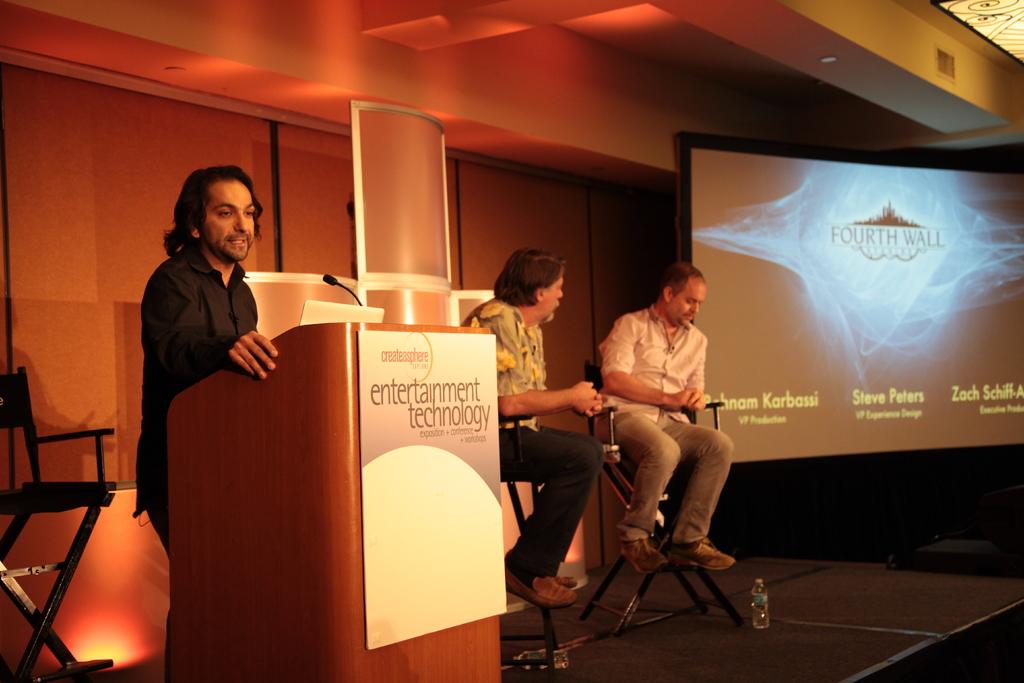What does the sign on podium say?
Offer a very short reply. Entertainment technology. 